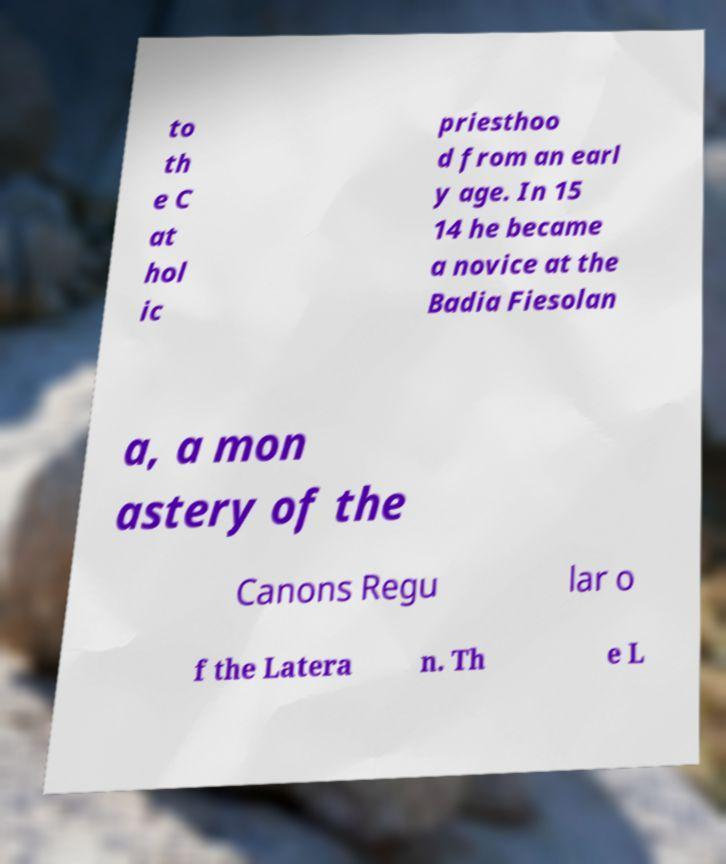I need the written content from this picture converted into text. Can you do that? to th e C at hol ic priesthoo d from an earl y age. In 15 14 he became a novice at the Badia Fiesolan a, a mon astery of the Canons Regu lar o f the Latera n. Th e L 